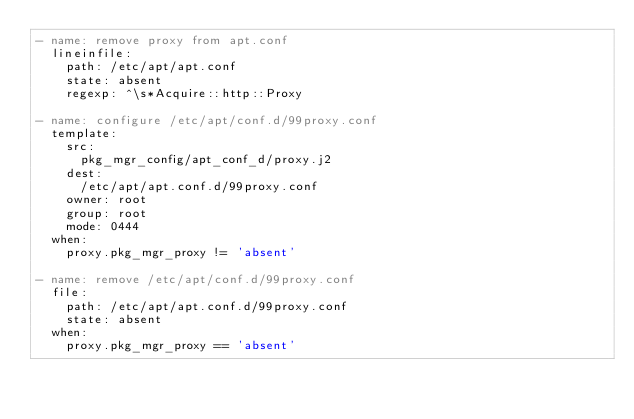<code> <loc_0><loc_0><loc_500><loc_500><_YAML_>- name: remove proxy from apt.conf
  lineinfile:
    path: /etc/apt/apt.conf
    state: absent
    regexp: ^\s*Acquire::http::Proxy

- name: configure /etc/apt/conf.d/99proxy.conf
  template:
    src:
      pkg_mgr_config/apt_conf_d/proxy.j2
    dest:
      /etc/apt/apt.conf.d/99proxy.conf
    owner: root
    group: root
    mode: 0444
  when:
    proxy.pkg_mgr_proxy != 'absent'

- name: remove /etc/apt/conf.d/99proxy.conf
  file:
    path: /etc/apt/apt.conf.d/99proxy.conf
    state: absent
  when:
    proxy.pkg_mgr_proxy == 'absent'
</code> 